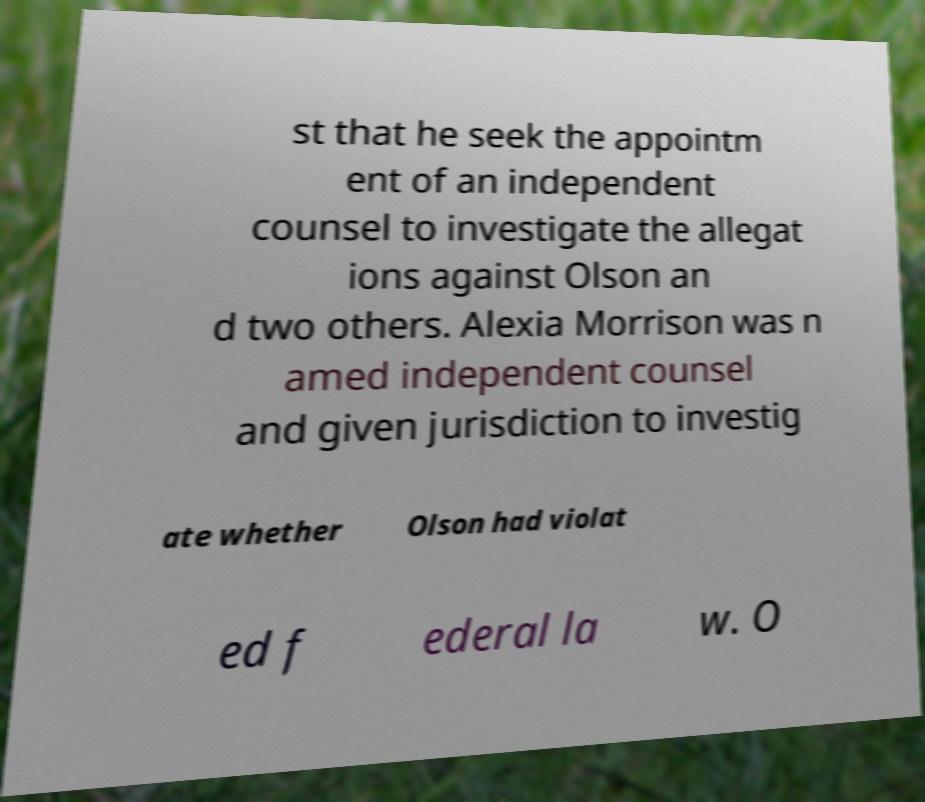Could you assist in decoding the text presented in this image and type it out clearly? st that he seek the appointm ent of an independent counsel to investigate the allegat ions against Olson an d two others. Alexia Morrison was n amed independent counsel and given jurisdiction to investig ate whether Olson had violat ed f ederal la w. O 